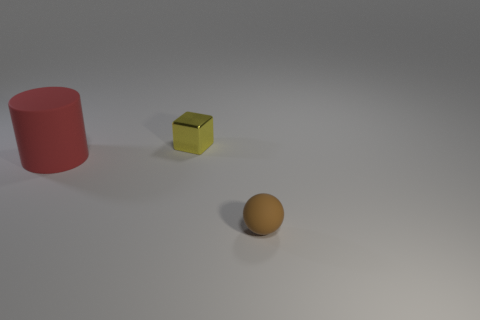Subtract all red spheres. Subtract all green cubes. How many spheres are left? 1 Subtract all yellow cylinders. How many red cubes are left? 0 Add 1 big reds. How many small browns exist? 0 Subtract all red cylinders. Subtract all small matte objects. How many objects are left? 1 Add 3 yellow metal objects. How many yellow metal objects are left? 4 Add 2 tiny brown rubber objects. How many tiny brown rubber objects exist? 3 Add 3 big metal balls. How many objects exist? 6 Subtract 0 brown blocks. How many objects are left? 3 Subtract all cubes. How many objects are left? 2 Subtract 1 cylinders. How many cylinders are left? 0 